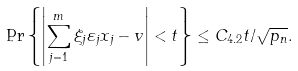<formula> <loc_0><loc_0><loc_500><loc_500>\Pr \left \{ \left | \sum _ { j = 1 } ^ { m } \xi _ { j } \varepsilon _ { j } x _ { j } - v \right | < t \right \} \leq C _ { 4 . 2 } t / \sqrt { p _ { n } } .</formula> 